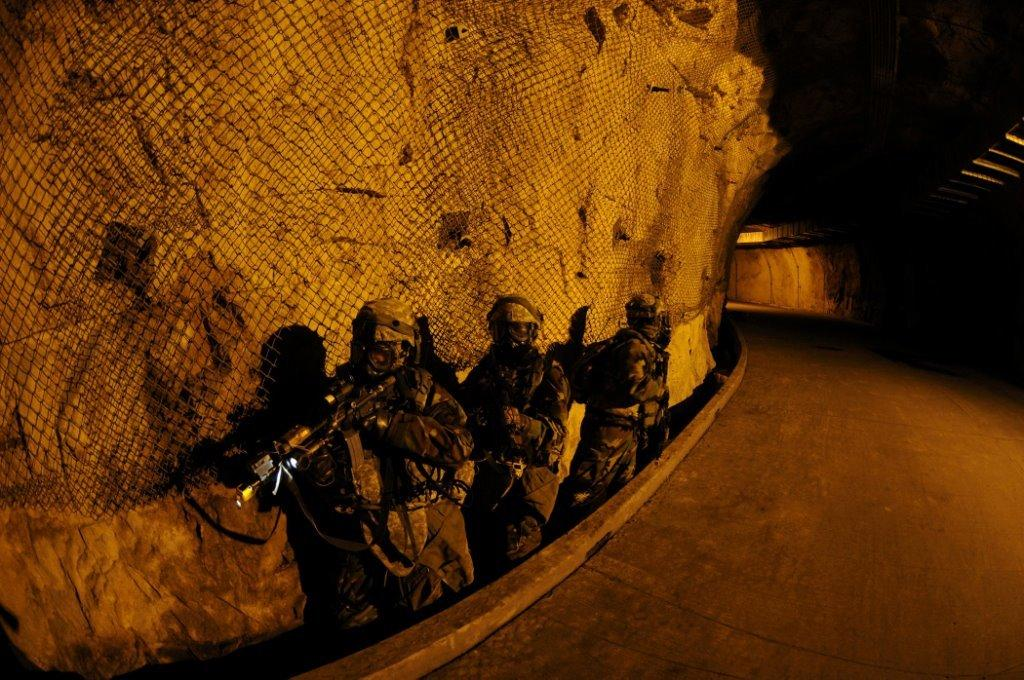What are the people in the image wearing? The people in the image are wearing similar costumes. What are the people holding in their hands? The people are holding weapons. What can be seen beside the people in the image? There is a path beside the people. What is visible in the background of the image? There is a net visible in the background of the image. What type of hat can be seen on the clam in the image? There is no clam or hat present in the image. 